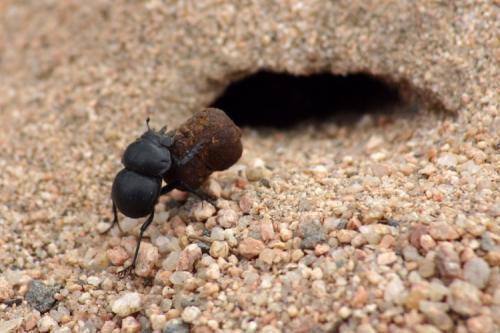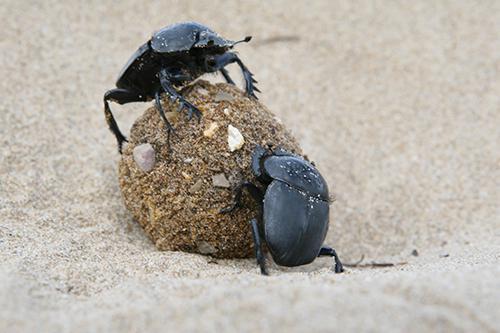The first image is the image on the left, the second image is the image on the right. For the images shown, is this caption "A beetle is in the 11 o'clock position on top of a dung ball." true? Answer yes or no. Yes. The first image is the image on the left, the second image is the image on the right. Considering the images on both sides, is "One image shows one beetle in contact with a round shape, and the other image includes a mass of small dark round things." valid? Answer yes or no. No. 